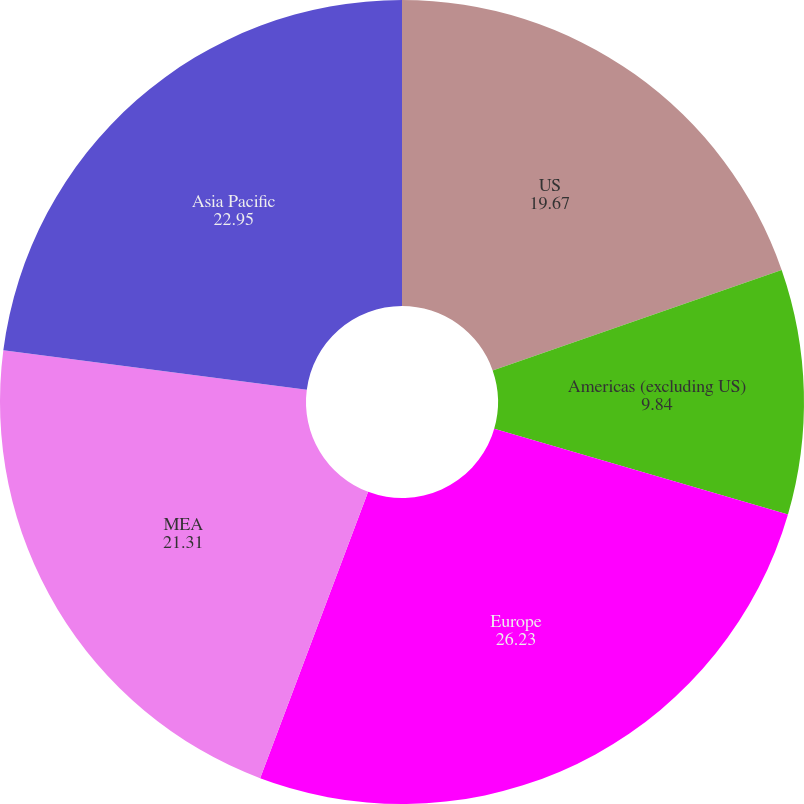Convert chart. <chart><loc_0><loc_0><loc_500><loc_500><pie_chart><fcel>US<fcel>Americas (excluding US)<fcel>Europe<fcel>MEA<fcel>Asia Pacific<nl><fcel>19.67%<fcel>9.84%<fcel>26.23%<fcel>21.31%<fcel>22.95%<nl></chart> 